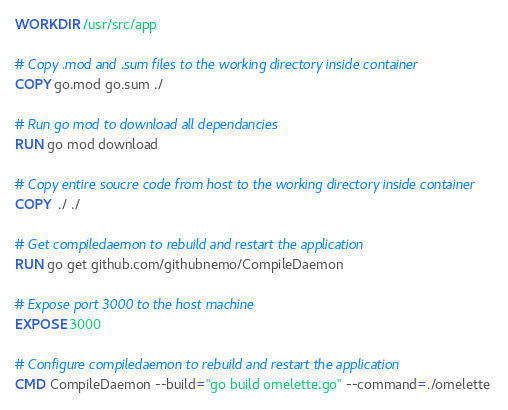Convert code to text. <code><loc_0><loc_0><loc_500><loc_500><_Dockerfile_>WORKDIR /usr/src/app

# Copy .mod and .sum files to the working directory inside container
COPY go.mod go.sum ./

# Run go mod to download all dependancies
RUN go mod download

# Copy entire soucre code from host to the working directory inside container
COPY  ./ ./

# Get compiledaemon to rebuild and restart the application
RUN go get github.com/githubnemo/CompileDaemon

# Expose port 3000 to the host machine
EXPOSE 3000

# Configure compiledaemon to rebuild and restart the application
CMD CompileDaemon --build="go build omelette.go" --command=./omelette



</code> 